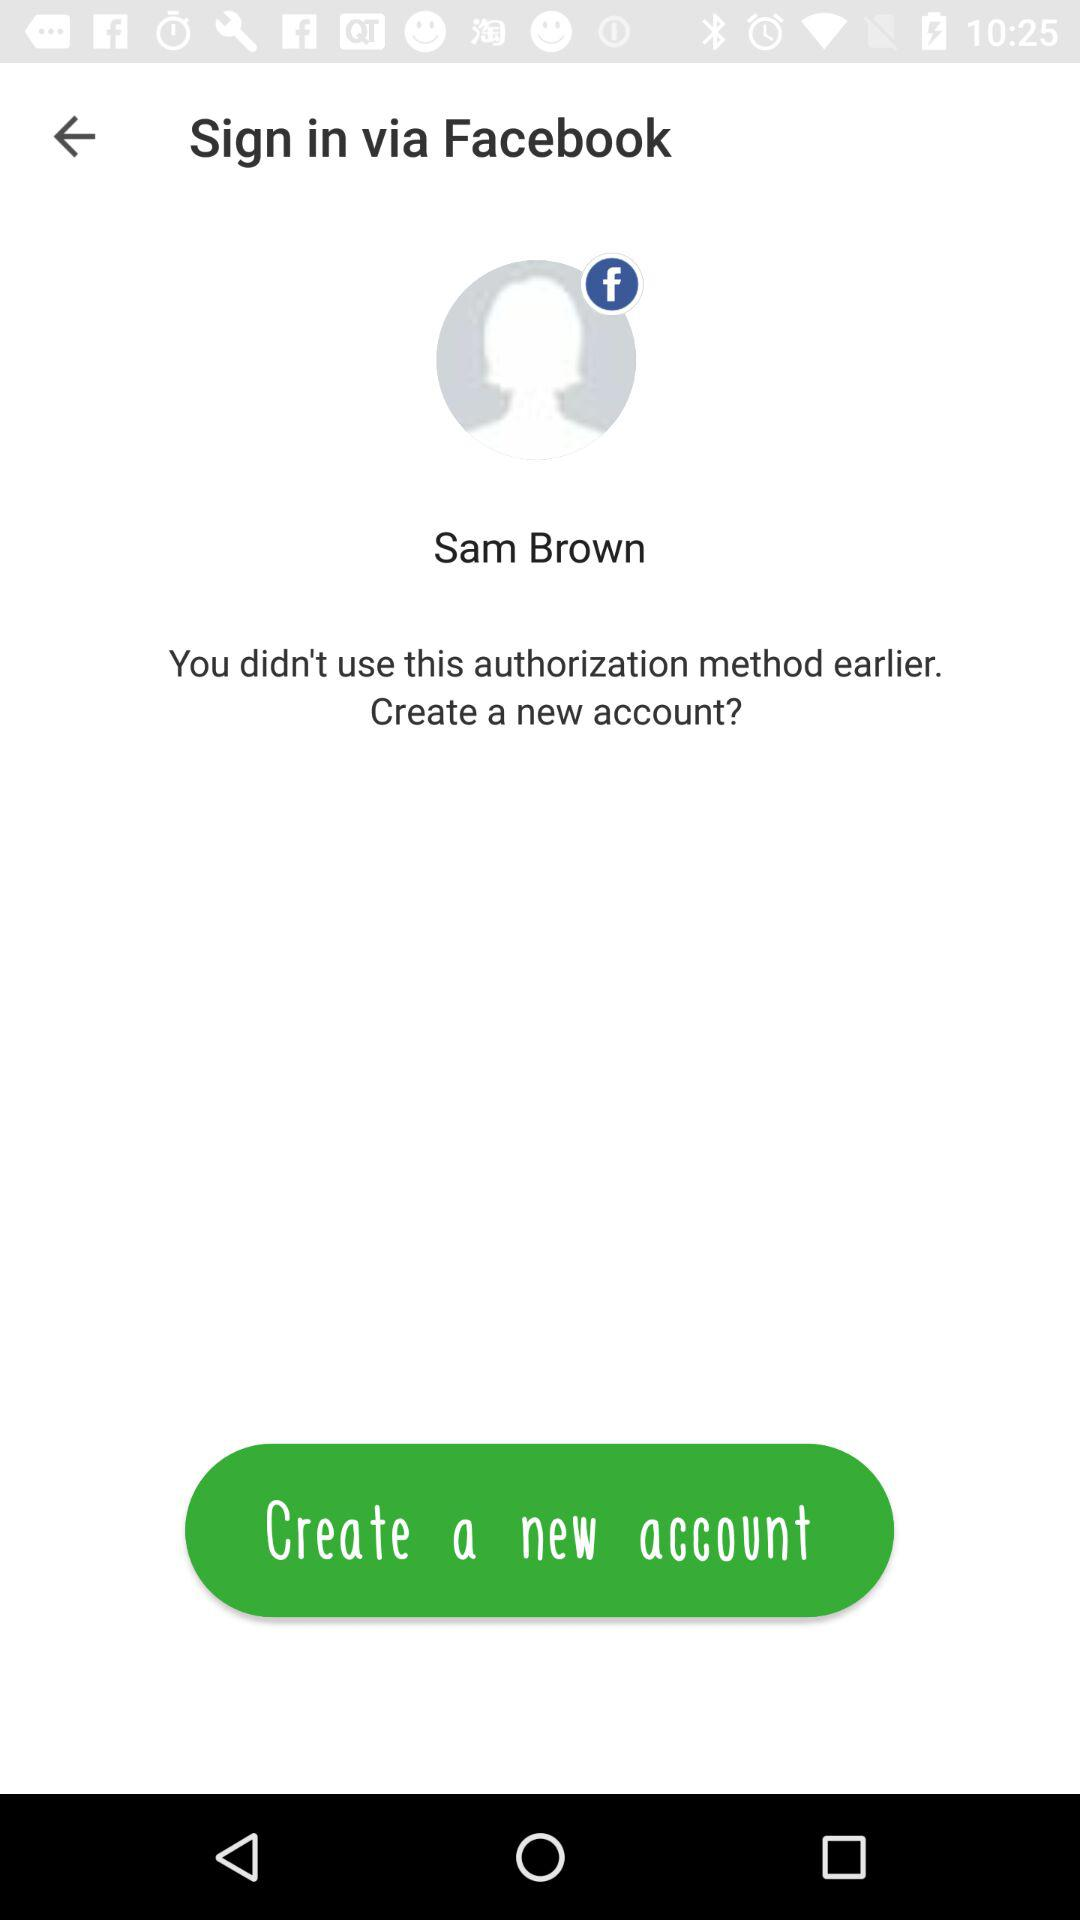What is the username? The username is "Sam Brown". 